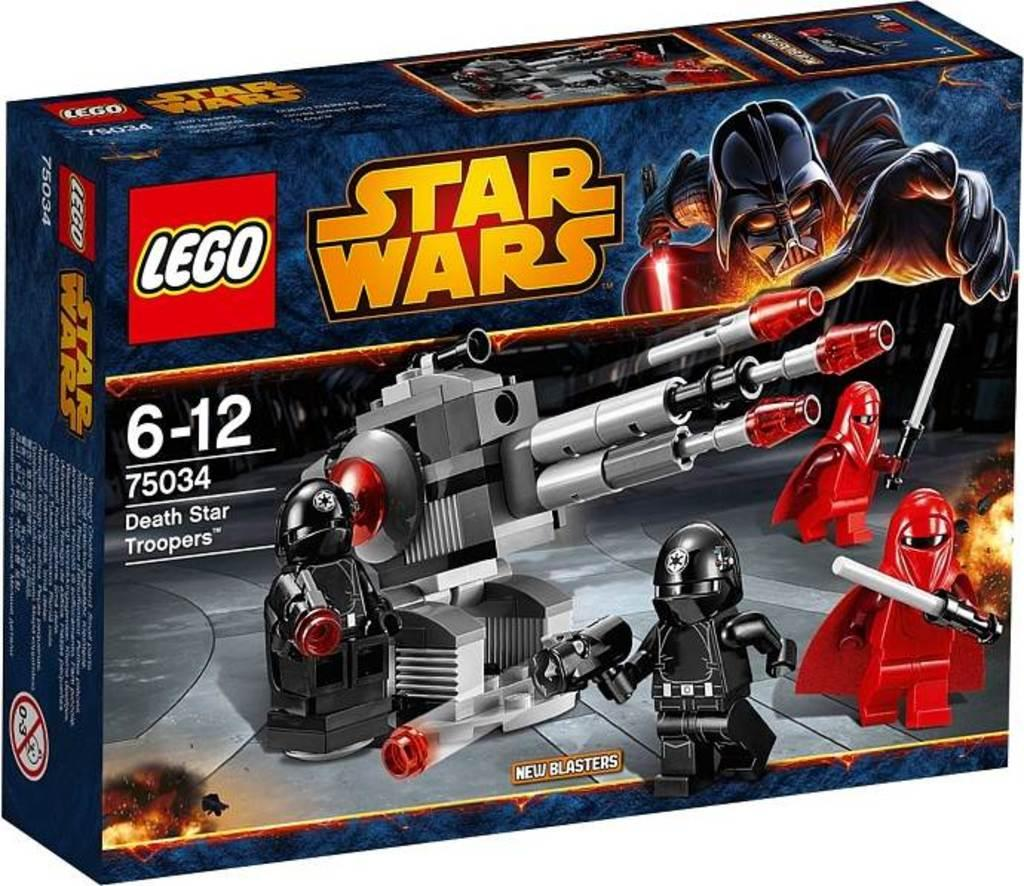<image>
Present a compact description of the photo's key features. A box contains a Star Wars Lego set for ages 6-12. 